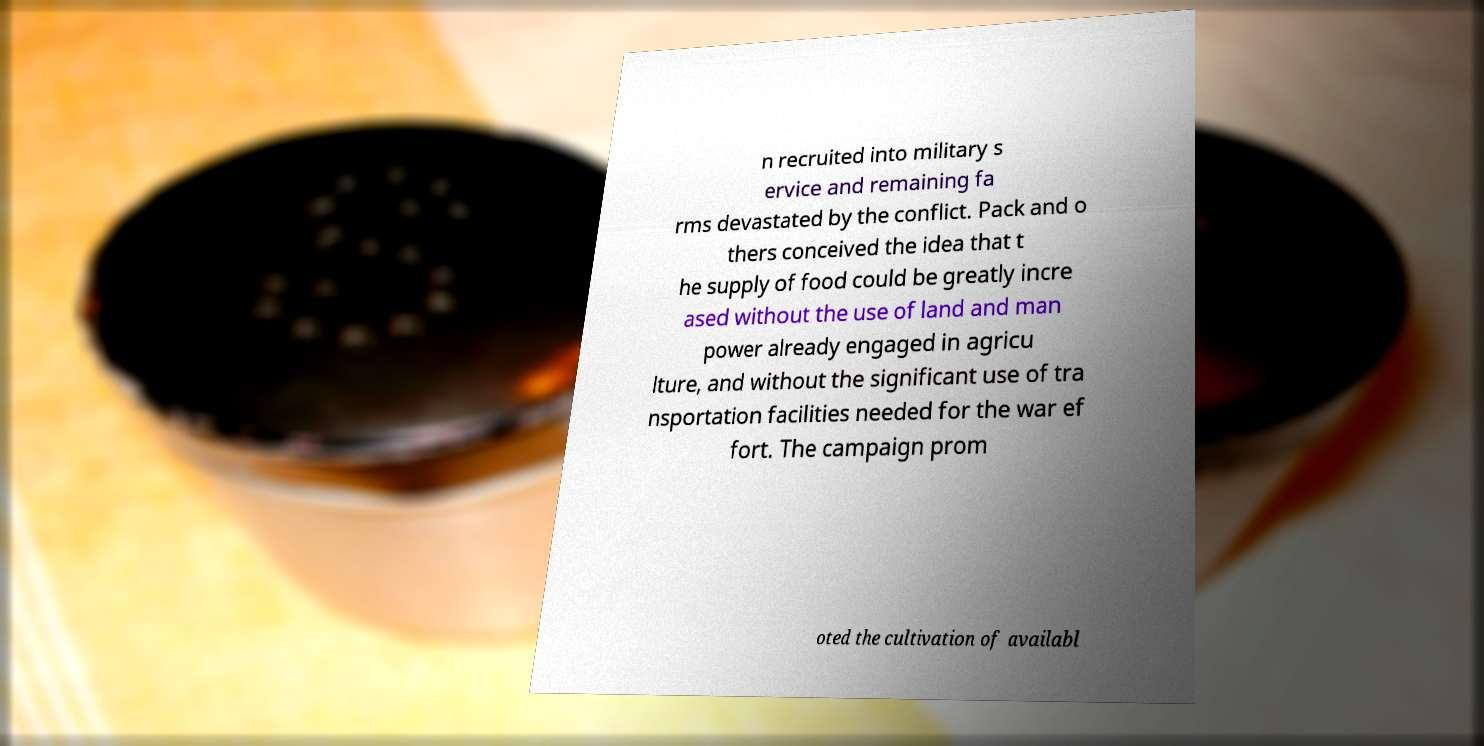What messages or text are displayed in this image? I need them in a readable, typed format. n recruited into military s ervice and remaining fa rms devastated by the conflict. Pack and o thers conceived the idea that t he supply of food could be greatly incre ased without the use of land and man power already engaged in agricu lture, and without the significant use of tra nsportation facilities needed for the war ef fort. The campaign prom oted the cultivation of availabl 